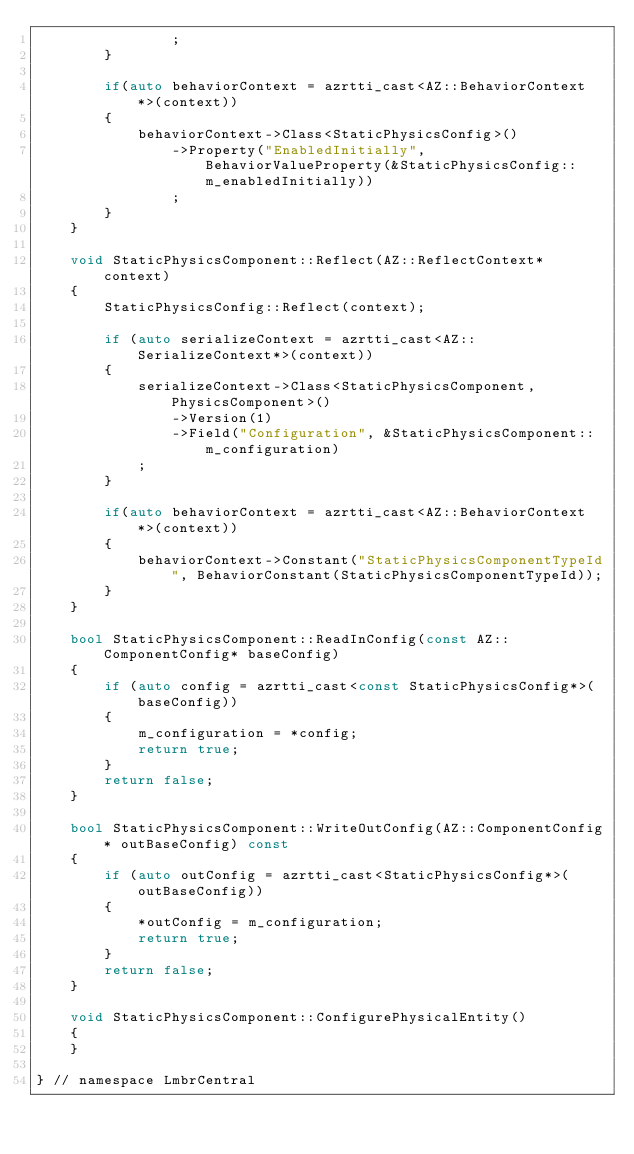Convert code to text. <code><loc_0><loc_0><loc_500><loc_500><_C++_>                ;
        }

        if(auto behaviorContext = azrtti_cast<AZ::BehaviorContext*>(context))
        {
            behaviorContext->Class<StaticPhysicsConfig>()
                ->Property("EnabledInitially", BehaviorValueProperty(&StaticPhysicsConfig::m_enabledInitially))
                ;
        }
    }

    void StaticPhysicsComponent::Reflect(AZ::ReflectContext* context)
    {
        StaticPhysicsConfig::Reflect(context);

        if (auto serializeContext = azrtti_cast<AZ::SerializeContext*>(context))
        {
            serializeContext->Class<StaticPhysicsComponent, PhysicsComponent>()
                ->Version(1)
                ->Field("Configuration", &StaticPhysicsComponent::m_configuration)
            ;
        }

        if(auto behaviorContext = azrtti_cast<AZ::BehaviorContext*>(context))
        {
            behaviorContext->Constant("StaticPhysicsComponentTypeId", BehaviorConstant(StaticPhysicsComponentTypeId));
        }
    }

    bool StaticPhysicsComponent::ReadInConfig(const AZ::ComponentConfig* baseConfig)
    {
        if (auto config = azrtti_cast<const StaticPhysicsConfig*>(baseConfig))
        {
            m_configuration = *config;
            return true;
        }
        return false;
    }

    bool StaticPhysicsComponent::WriteOutConfig(AZ::ComponentConfig* outBaseConfig) const
    {
        if (auto outConfig = azrtti_cast<StaticPhysicsConfig*>(outBaseConfig))
        {
            *outConfig = m_configuration;
            return true;
        }
        return false;
    }

    void StaticPhysicsComponent::ConfigurePhysicalEntity()
    {
    }

} // namespace LmbrCentral
</code> 